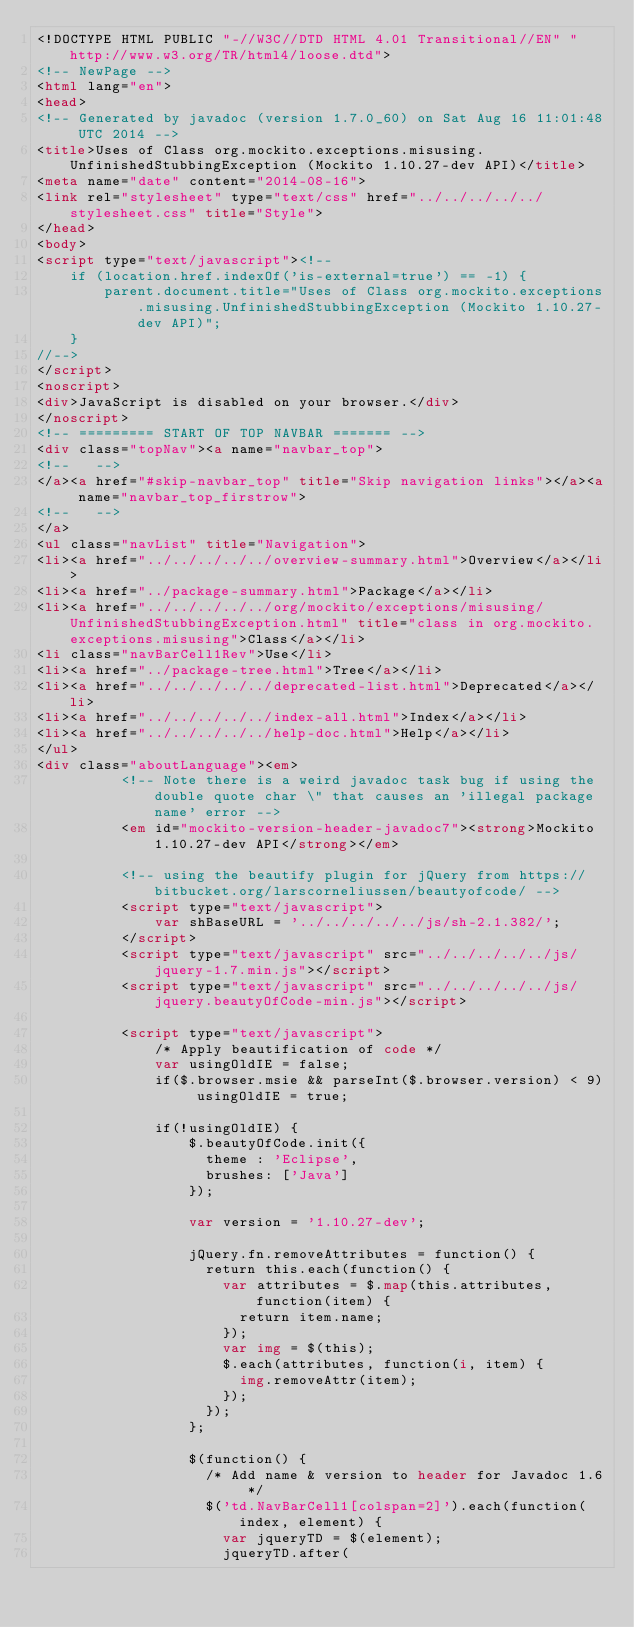Convert code to text. <code><loc_0><loc_0><loc_500><loc_500><_HTML_><!DOCTYPE HTML PUBLIC "-//W3C//DTD HTML 4.01 Transitional//EN" "http://www.w3.org/TR/html4/loose.dtd">
<!-- NewPage -->
<html lang="en">
<head>
<!-- Generated by javadoc (version 1.7.0_60) on Sat Aug 16 11:01:48 UTC 2014 -->
<title>Uses of Class org.mockito.exceptions.misusing.UnfinishedStubbingException (Mockito 1.10.27-dev API)</title>
<meta name="date" content="2014-08-16">
<link rel="stylesheet" type="text/css" href="../../../../../stylesheet.css" title="Style">
</head>
<body>
<script type="text/javascript"><!--
    if (location.href.indexOf('is-external=true') == -1) {
        parent.document.title="Uses of Class org.mockito.exceptions.misusing.UnfinishedStubbingException (Mockito 1.10.27-dev API)";
    }
//-->
</script>
<noscript>
<div>JavaScript is disabled on your browser.</div>
</noscript>
<!-- ========= START OF TOP NAVBAR ======= -->
<div class="topNav"><a name="navbar_top">
<!--   -->
</a><a href="#skip-navbar_top" title="Skip navigation links"></a><a name="navbar_top_firstrow">
<!--   -->
</a>
<ul class="navList" title="Navigation">
<li><a href="../../../../../overview-summary.html">Overview</a></li>
<li><a href="../package-summary.html">Package</a></li>
<li><a href="../../../../../org/mockito/exceptions/misusing/UnfinishedStubbingException.html" title="class in org.mockito.exceptions.misusing">Class</a></li>
<li class="navBarCell1Rev">Use</li>
<li><a href="../package-tree.html">Tree</a></li>
<li><a href="../../../../../deprecated-list.html">Deprecated</a></li>
<li><a href="../../../../../index-all.html">Index</a></li>
<li><a href="../../../../../help-doc.html">Help</a></li>
</ul>
<div class="aboutLanguage"><em>
          <!-- Note there is a weird javadoc task bug if using the double quote char \" that causes an 'illegal package name' error -->
          <em id="mockito-version-header-javadoc7"><strong>Mockito 1.10.27-dev API</strong></em>

          <!-- using the beautify plugin for jQuery from https://bitbucket.org/larscorneliussen/beautyofcode/ -->
          <script type="text/javascript">
              var shBaseURL = '../../../../../js/sh-2.1.382/';
          </script>
          <script type="text/javascript" src="../../../../../js/jquery-1.7.min.js"></script>
          <script type="text/javascript" src="../../../../../js/jquery.beautyOfCode-min.js"></script>

          <script type="text/javascript">
              /* Apply beautification of code */
              var usingOldIE = false;
              if($.browser.msie && parseInt($.browser.version) < 9) usingOldIE = true;

              if(!usingOldIE) {
                  $.beautyOfCode.init({
                    theme : 'Eclipse',
                    brushes: ['Java']
                  });

                  var version = '1.10.27-dev';

                  jQuery.fn.removeAttributes = function() {
                    return this.each(function() {
                      var attributes = $.map(this.attributes, function(item) {
                        return item.name;
                      });
                      var img = $(this);
                      $.each(attributes, function(i, item) {
                        img.removeAttr(item);
                      });
                    });
                  };

                  $(function() {
                    /* Add name & version to header for Javadoc 1.6 */
                    $('td.NavBarCell1[colspan=2]').each(function(index, element) {
                      var jqueryTD = $(element);
                      jqueryTD.after(</code> 